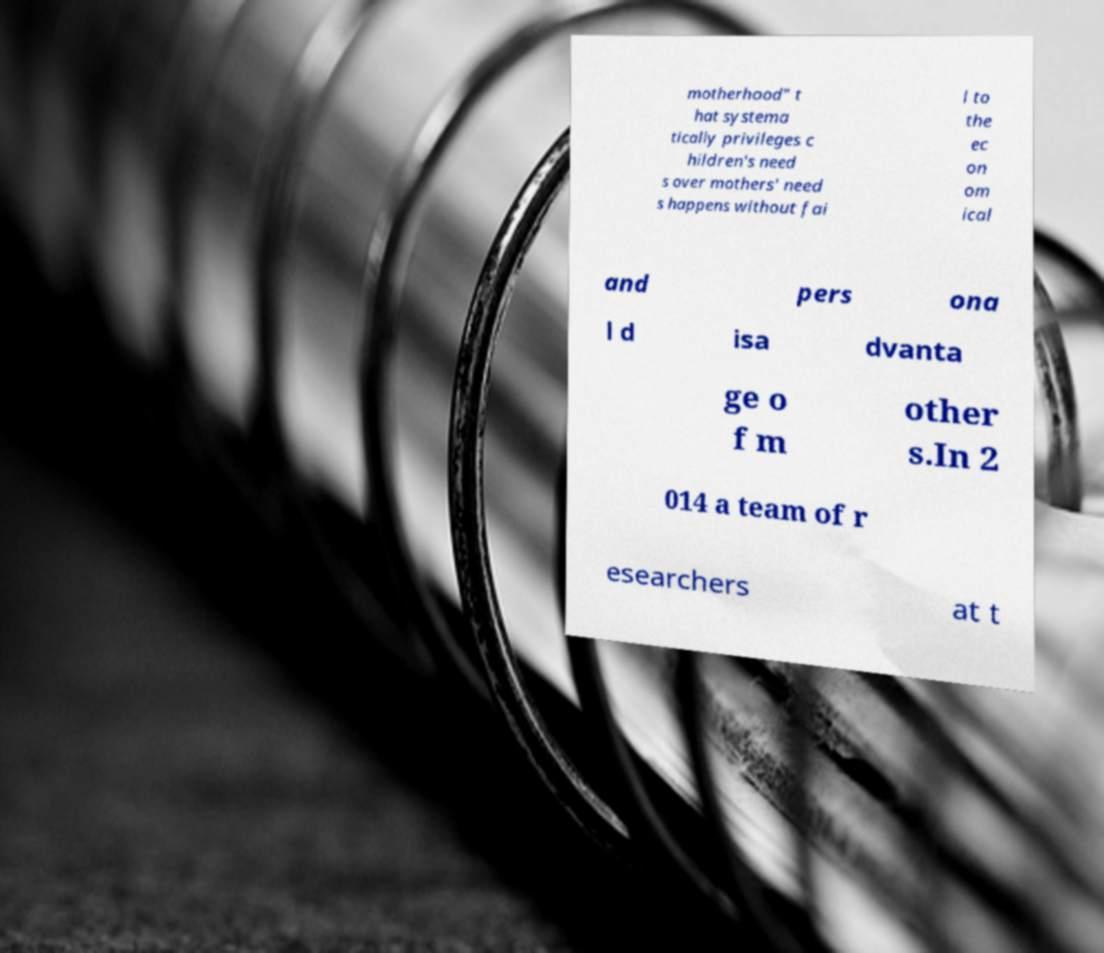I need the written content from this picture converted into text. Can you do that? motherhood" t hat systema tically privileges c hildren's need s over mothers' need s happens without fai l to the ec on om ical and pers ona l d isa dvanta ge o f m other s.In 2 014 a team of r esearchers at t 